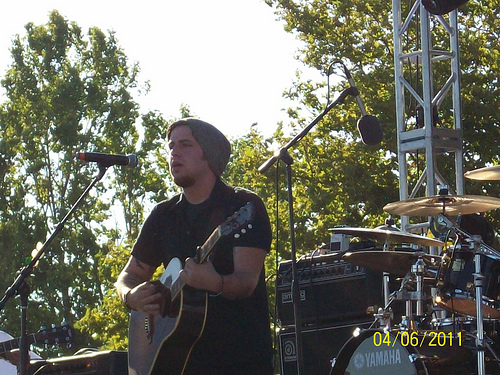<image>
Can you confirm if the man is on the guitar? No. The man is not positioned on the guitar. They may be near each other, but the man is not supported by or resting on top of the guitar. Where is the man in relation to the guitar? Is it behind the guitar? Yes. From this viewpoint, the man is positioned behind the guitar, with the guitar partially or fully occluding the man. 